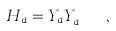Convert formula to latex. <formula><loc_0><loc_0><loc_500><loc_500>H _ { a } = Y _ { a } Y _ { a } ^ { \dagger } \ \ ,</formula> 